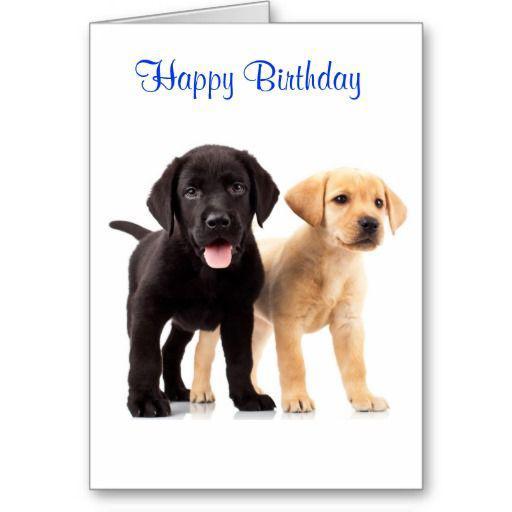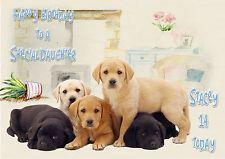The first image is the image on the left, the second image is the image on the right. Assess this claim about the two images: "there are five dogs in the image on the right.". Correct or not? Answer yes or no. Yes. The first image is the image on the left, the second image is the image on the right. Assess this claim about the two images: "One image shows exactly two puppies, including a black one.". Correct or not? Answer yes or no. Yes. 